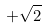<formula> <loc_0><loc_0><loc_500><loc_500>+ \sqrt { 2 }</formula> 